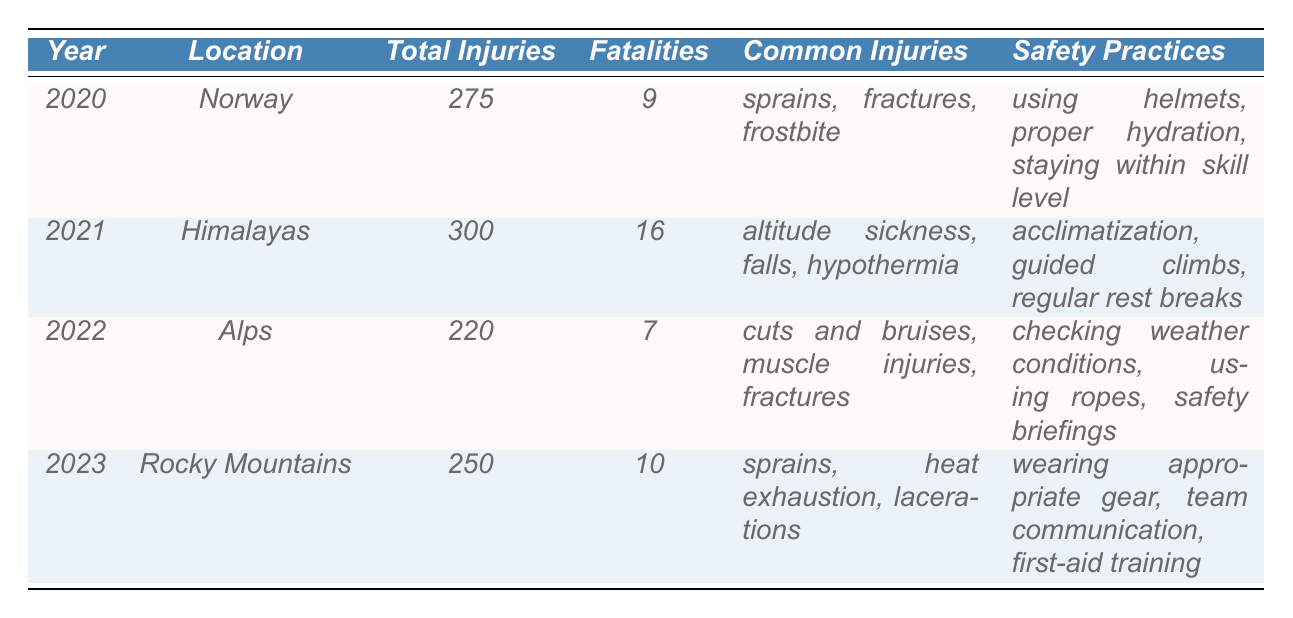What was the total number of injuries recorded in the Himalayas in 2021? Referring to the table, the total injuries for the Himalayas in 2021 is clearly listed as 300.
Answer: 300 Which location had the highest number of fatalities? By comparing the fatality numbers from each location, the table shows that the Himalayas in 2021 had the highest fatalities, which is 16.
Answer: Himalayas What is the common injury for Norway in 2020? The table indicates that common injuries in Norway for 2020 included sprains, fractures, and frostbite.
Answer: Sprains, fractures, frostbite What was the difference in total injuries between 2021 and 2022? The total injuries in 2021 for the Himalayas is 300, and for 2022 in the Alps, it's 220. The difference is calculated as 300 - 220 = 80.
Answer: 80 Were there any fatalities in the Alps in 2022? The table shows that in the Alps in 2022, the number of fatalities is recorded as 7, indicating that there were indeed fatalities.
Answer: Yes What is the average number of injuries from 2020 to 2023? To find the average, sum the total injuries (275 + 300 + 220 + 250 = 1045) and divide by the number of years (4). So, 1045 / 4 = 261.25.
Answer: 261.25 Which year had the least total injuries, and how many were there? Looking through the data, the year 2022 in the Alps had the least total injuries at 220.
Answer: 2022, 220 Is "proper hydration" a safety practice mentioned in the table? By reviewing the safety practices for Norway in 2020, it confirms that "proper hydration" is indeed listed as a safety practice.
Answer: Yes What was the trend in fatalities from 2020 to 2023? Analyzing the fatalities: 9 (2020), 16 (2021), 7 (2022), 10 (2023) shows that fatalities peaked in 2021, decreased in 2022, and then increased slightly in 2023.
Answer: Peak in 2021, decrease in 2022, slight increase in 2023 In which year did the Rocky Mountains report "heat exhaustion" as a common injury? The table specifically notes that heat exhaustion was listed as a common injury in the Rocky Mountains in 2023.
Answer: 2023 